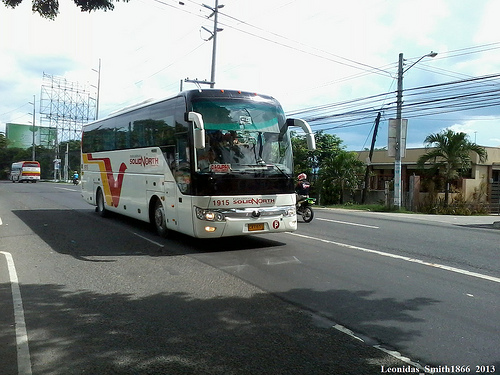What are the different objects that can be seen along the street? Along the street, you can see a utility pole with many utility lines, a few trees including a palm tree, another bus in the background, and street signs. 